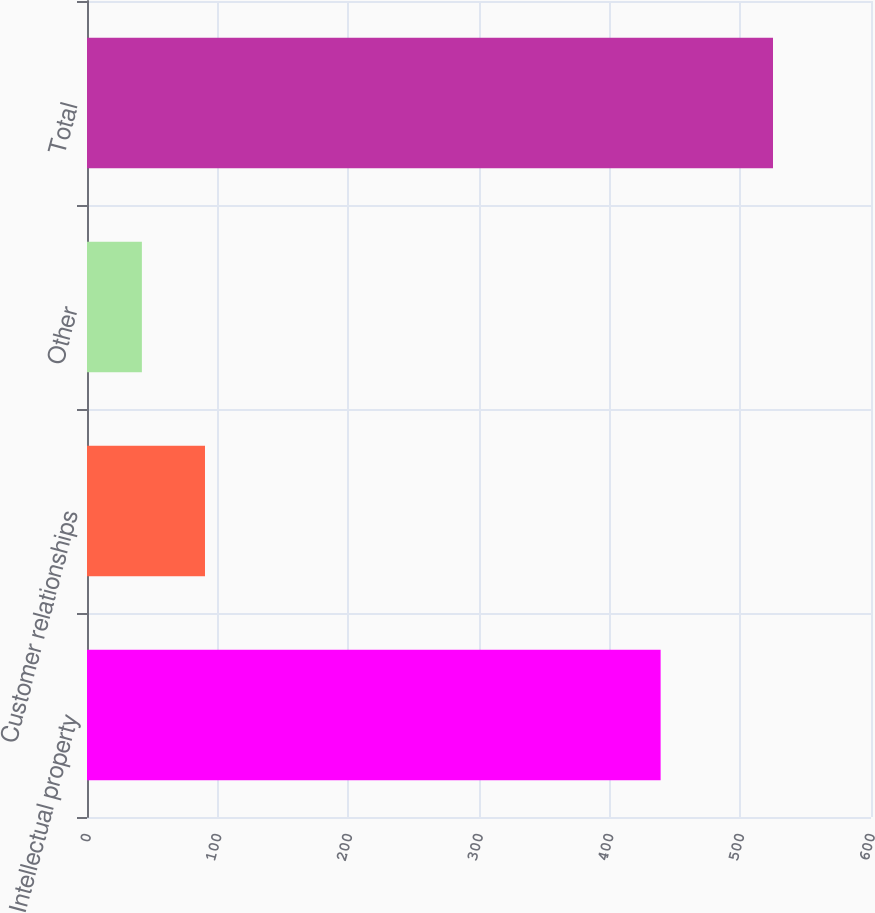<chart> <loc_0><loc_0><loc_500><loc_500><bar_chart><fcel>Intellectual property<fcel>Customer relationships<fcel>Other<fcel>Total<nl><fcel>439<fcel>90.3<fcel>42<fcel>525<nl></chart> 